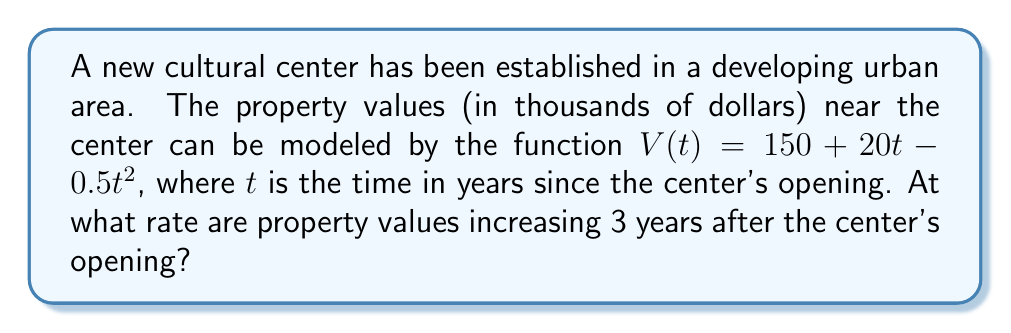Provide a solution to this math problem. To find the rate at which property values are increasing 3 years after the center's opening, we need to calculate the derivative of the given function and evaluate it at $t = 3$.

Step 1: Find the derivative of $V(t)$.
$$V(t) = 150 + 20t - 0.5t^2$$
$$V'(t) = 20 - t$$

Step 2: Evaluate $V'(t)$ at $t = 3$.
$$V'(3) = 20 - 3 = 17$$

Step 3: Interpret the result.
The derivative $V'(t)$ represents the rate of change of property values with respect to time. At $t = 3$, $V'(3) = 17$, which means that 3 years after the center's opening, property values are increasing at a rate of 17 thousand dollars per year.
Answer: $17$ thousand dollars per year 